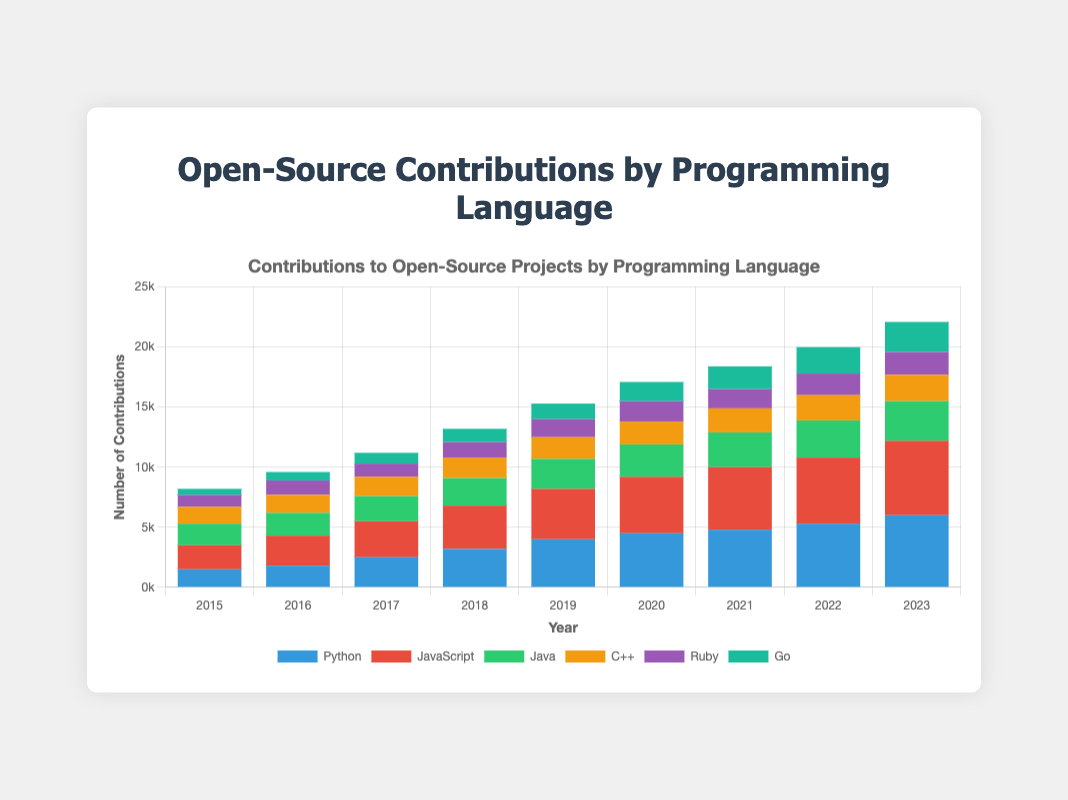What is the total number of contributions in 2023? To find the total number of contributions in 2023, sum the contributions of all programming languages for that year: Python (6000) + JavaScript (6200) + Java (3300) + C++ (2200) + Ruby (1900) + Go (2500) = 22100
Answer: 22100 Which programming language had the highest contributions in 2017? Compare the number of contributions for each programming language in 2017. Python (2500), JavaScript (3000), Java (2100), C++ (1600), Ruby (1100), Go (900). JavaScript had the highest contributions with 3000
Answer: JavaScript By how much did Python's contributions increase from 2015 to 2023? Subtract Python's contributions in 2015 from those in 2023: 6000 (in 2023) - 1500 (in 2015) = 4500
Answer: 4500 Which year saw the greatest total number of contributions across all programming languages? Calculate the sum of contributions for all languages for each year and compare them: 2015 (8200), 2016 (9600), 2017 (11000), 2018 (13100), 2019 (14800), 2020 (17100), 2021 (18400), 2022 (20000), 2023 (22100). The year 2023 had the greatest total number of contributions with 22100
Answer: 2023 Which language showed the smallest growth in contributions from 2015 to 2023? Calculate the increase in contributions for each language from 2015 to 2023: Python (4500), JavaScript (4200), Java (1500), C++ (800), Ruby (900), Go (2000). C++ showed the smallest growth with an increase of 800 contributions
Answer: C++ Compare the contributions of Go and Ruby in 2020. Which had more, and by how much? Go had 1600 contributions, Ruby had 1700 contributions in 2020. Ruby had more by 1700 - 1600 = 100 contributions
Answer: Ruby by 100 During which year did Java surpass 3000 contributions? Look at the contributions data for Java: 2015 (1800), 2016 (1900), 2017 (2100), 2018 (2300), 2019 (2500), 2020 (2700), 2021 (2900), 2022 (3100), 2023 (3300). Java surpassed 3000 in 2022 with 3100 contributions
Answer: 2022 What's the average number of contributions for JavaScript from 2015 to 2023? Calculate the average by summing the contributions across all years and dividing by the number of years: (2000 + 2500 + 3000 + 3600 + 4200 + 4700 + 5200 + 5500 + 6200) / 9 = 41000 / 9 ≈ 4555.56
Answer: 4555.56 Which language had the most consistent increase in contributions year over year? Examine the annual contribution changes: Python (300, 700, 700, 800, 500, 300, 500, 700), JavaScript (500, 500, 600, 600, 500, 500, 300, 700), Java (100, 200, 200, 200, 200, 200, 200, 200), C++ (100, 100, 100, 100, 100, 100, 100, 100), Ruby (200, -100, 200, 200, 200, -100, 200, 100), Go (200, 200, 200, 200, 300, 300, 300, 300). Java had the most consistent increase of 200 each year
Answer: Java 